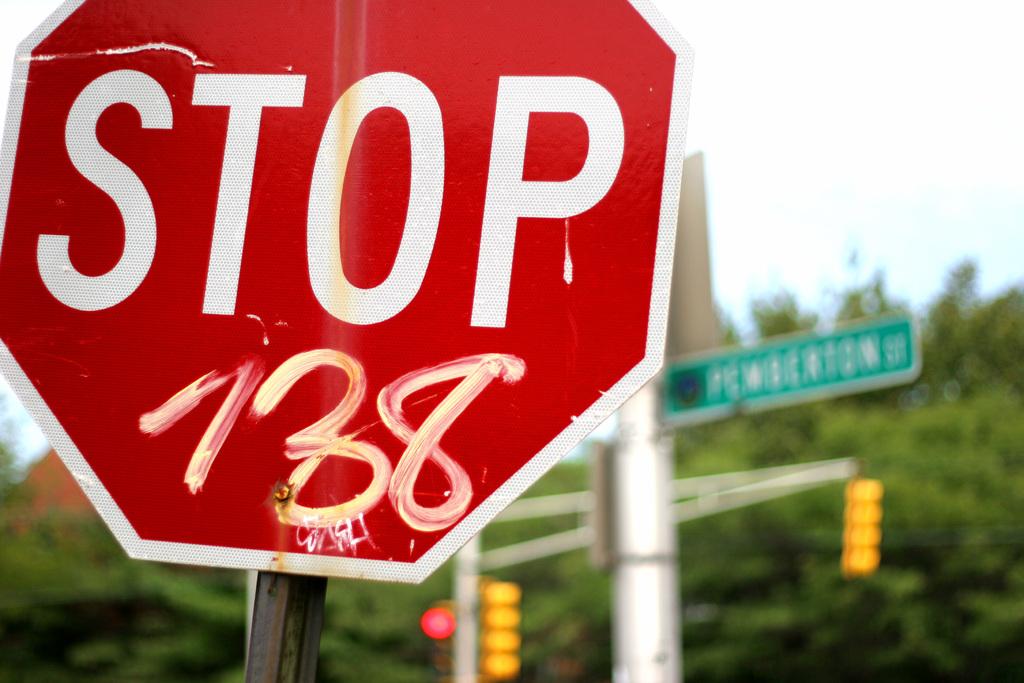Is that a stop sign?
Make the answer very short. Yes. Is there graffiti on the sign?
Your answer should be very brief. Yes. 